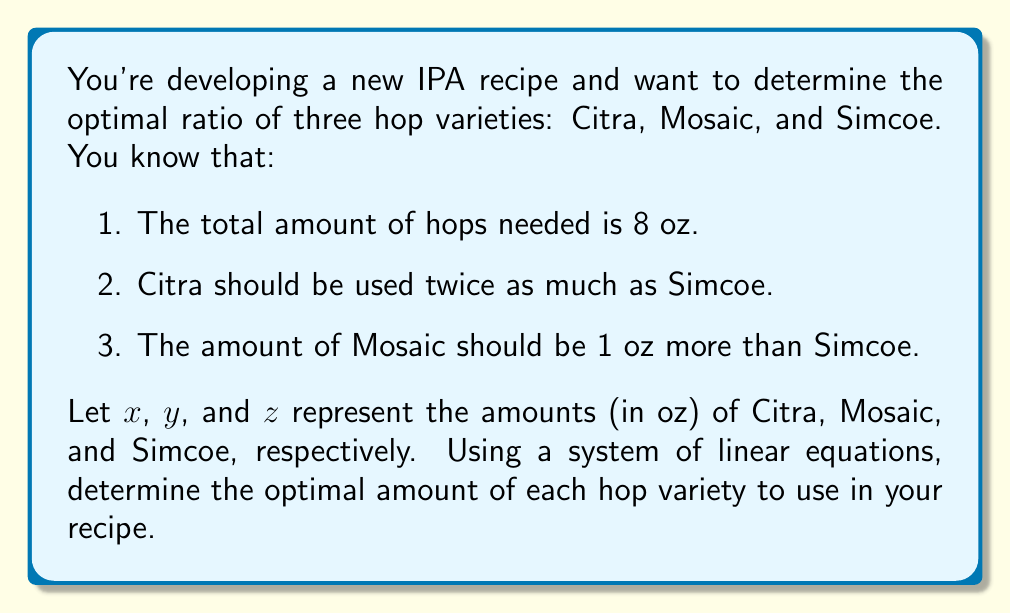Help me with this question. Let's approach this step-by-step using a system of linear equations:

1. First, we can express the given information as equations:

   Total hops: $x + y + z = 8$ (Equation 1)
   Citra vs Simcoe: $x = 2z$ (Equation 2)
   Mosaic vs Simcoe: $y = z + 1$ (Equation 3)

2. We can substitute Equation 2 and Equation 3 into Equation 1:

   $(2z) + (z + 1) + z = 8$

3. Simplify:

   $2z + z + 1 + z = 8$
   $4z + 1 = 8$

4. Solve for $z$:

   $4z = 7$
   $z = \frac{7}{4} = 1.75$

5. Now that we know $z$ (Simcoe), we can find $x$ (Citra) using Equation 2:

   $x = 2z = 2(1.75) = 3.5$

6. And we can find $y$ (Mosaic) using Equation 3:

   $y = z + 1 = 1.75 + 1 = 2.75$

Therefore, the optimal amounts are:
Citra (x): 3.5 oz
Mosaic (y): 2.75 oz
Simcoe (z): 1.75 oz
Answer: Citra: 3.5 oz, Mosaic: 2.75 oz, Simcoe: 1.75 oz 